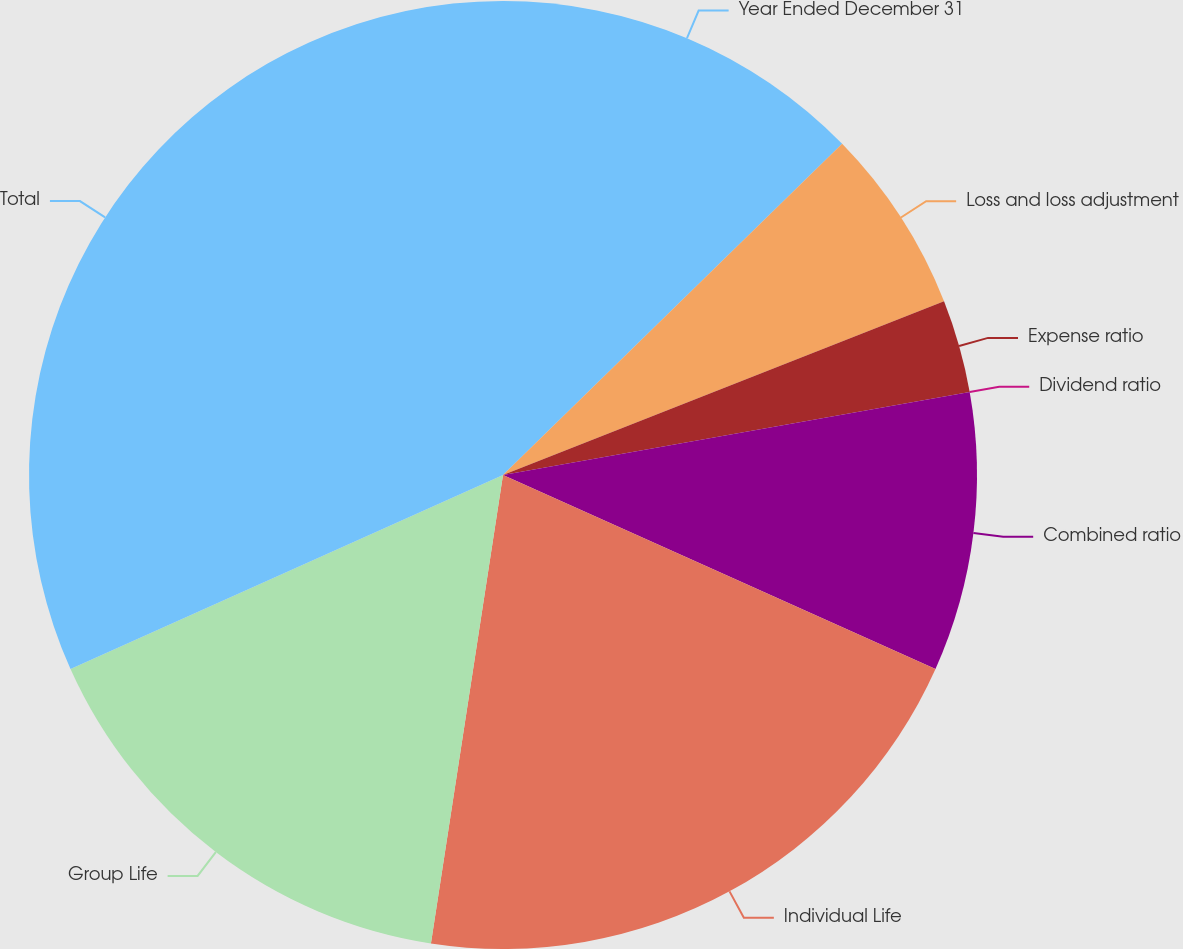Convert chart to OTSL. <chart><loc_0><loc_0><loc_500><loc_500><pie_chart><fcel>Year Ended December 31<fcel>Loss and loss adjustment<fcel>Expense ratio<fcel>Dividend ratio<fcel>Combined ratio<fcel>Individual Life<fcel>Group Life<fcel>Total<nl><fcel>12.69%<fcel>6.34%<fcel>3.17%<fcel>0.0%<fcel>9.51%<fcel>20.72%<fcel>15.86%<fcel>31.71%<nl></chart> 